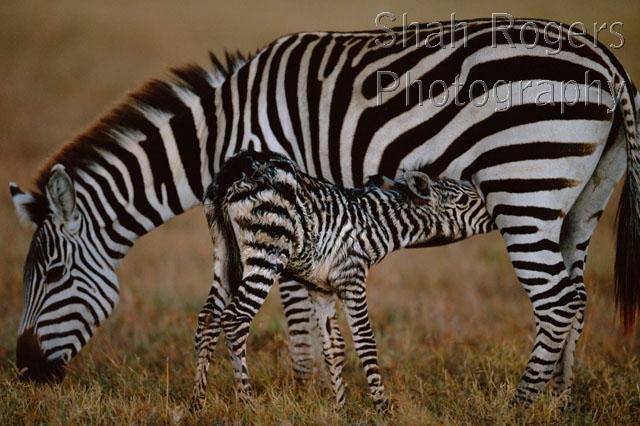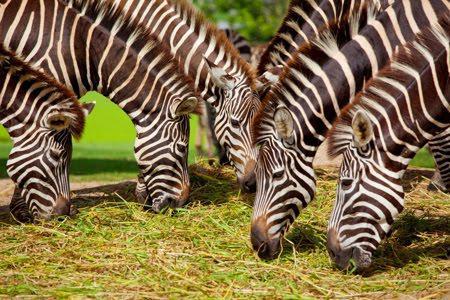The first image is the image on the left, the second image is the image on the right. Given the left and right images, does the statement "A baby zebra is shown nursing in one image." hold true? Answer yes or no. Yes. The first image is the image on the left, the second image is the image on the right. Analyze the images presented: Is the assertion "There is a baby zebra eating from its mother zebra." valid? Answer yes or no. Yes. 